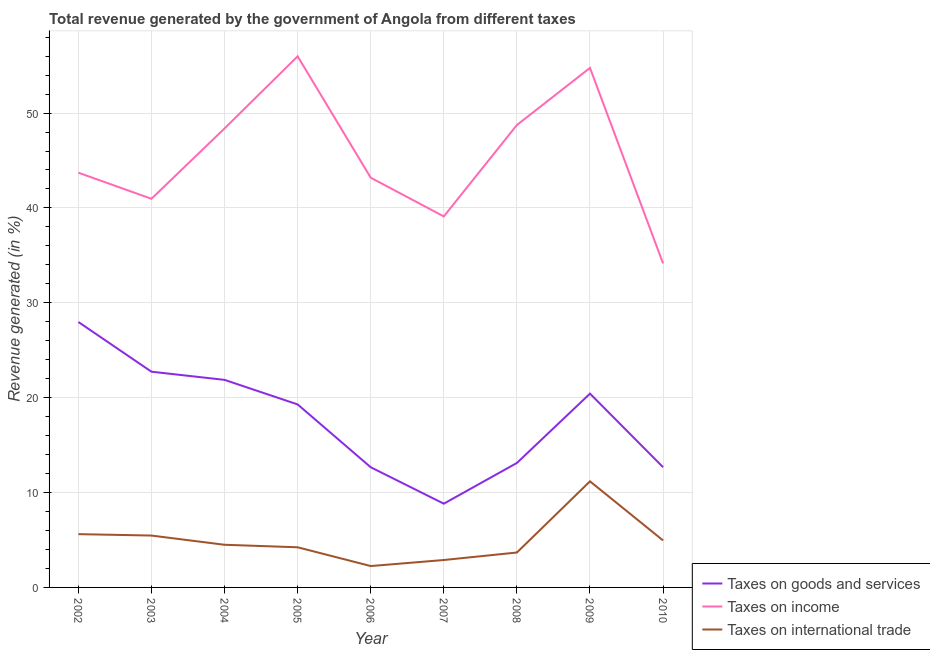Does the line corresponding to percentage of revenue generated by taxes on income intersect with the line corresponding to percentage of revenue generated by tax on international trade?
Your answer should be very brief. No. Is the number of lines equal to the number of legend labels?
Keep it short and to the point. Yes. What is the percentage of revenue generated by tax on international trade in 2007?
Your answer should be very brief. 2.89. Across all years, what is the maximum percentage of revenue generated by taxes on goods and services?
Offer a terse response. 27.98. Across all years, what is the minimum percentage of revenue generated by tax on international trade?
Your response must be concise. 2.25. In which year was the percentage of revenue generated by taxes on income minimum?
Your answer should be very brief. 2010. What is the total percentage of revenue generated by taxes on goods and services in the graph?
Offer a terse response. 159.6. What is the difference between the percentage of revenue generated by taxes on goods and services in 2002 and that in 2003?
Offer a very short reply. 5.24. What is the difference between the percentage of revenue generated by tax on international trade in 2006 and the percentage of revenue generated by taxes on goods and services in 2002?
Offer a very short reply. -25.73. What is the average percentage of revenue generated by tax on international trade per year?
Offer a terse response. 4.97. In the year 2007, what is the difference between the percentage of revenue generated by tax on international trade and percentage of revenue generated by taxes on income?
Ensure brevity in your answer.  -36.22. In how many years, is the percentage of revenue generated by tax on international trade greater than 16 %?
Provide a succinct answer. 0. What is the ratio of the percentage of revenue generated by taxes on goods and services in 2008 to that in 2010?
Offer a very short reply. 1.04. Is the percentage of revenue generated by tax on international trade in 2003 less than that in 2008?
Offer a terse response. No. What is the difference between the highest and the second highest percentage of revenue generated by taxes on goods and services?
Offer a very short reply. 5.24. What is the difference between the highest and the lowest percentage of revenue generated by taxes on goods and services?
Make the answer very short. 19.15. Is it the case that in every year, the sum of the percentage of revenue generated by taxes on goods and services and percentage of revenue generated by taxes on income is greater than the percentage of revenue generated by tax on international trade?
Keep it short and to the point. Yes. Does the percentage of revenue generated by taxes on income monotonically increase over the years?
Make the answer very short. No. Is the percentage of revenue generated by taxes on goods and services strictly greater than the percentage of revenue generated by taxes on income over the years?
Ensure brevity in your answer.  No. How many lines are there?
Your response must be concise. 3. How many years are there in the graph?
Offer a very short reply. 9. What is the difference between two consecutive major ticks on the Y-axis?
Provide a succinct answer. 10. Does the graph contain any zero values?
Offer a terse response. No. Does the graph contain grids?
Give a very brief answer. Yes. How are the legend labels stacked?
Your response must be concise. Vertical. What is the title of the graph?
Offer a very short reply. Total revenue generated by the government of Angola from different taxes. Does "Unemployment benefits" appear as one of the legend labels in the graph?
Give a very brief answer. No. What is the label or title of the Y-axis?
Your answer should be very brief. Revenue generated (in %). What is the Revenue generated (in %) in Taxes on goods and services in 2002?
Provide a short and direct response. 27.98. What is the Revenue generated (in %) of Taxes on income in 2002?
Provide a short and direct response. 43.72. What is the Revenue generated (in %) in Taxes on international trade in 2002?
Your answer should be very brief. 5.62. What is the Revenue generated (in %) of Taxes on goods and services in 2003?
Offer a terse response. 22.74. What is the Revenue generated (in %) of Taxes on income in 2003?
Provide a short and direct response. 40.97. What is the Revenue generated (in %) of Taxes on international trade in 2003?
Keep it short and to the point. 5.47. What is the Revenue generated (in %) of Taxes on goods and services in 2004?
Provide a short and direct response. 21.88. What is the Revenue generated (in %) of Taxes on income in 2004?
Your answer should be compact. 48.38. What is the Revenue generated (in %) in Taxes on international trade in 2004?
Keep it short and to the point. 4.5. What is the Revenue generated (in %) of Taxes on goods and services in 2005?
Keep it short and to the point. 19.29. What is the Revenue generated (in %) of Taxes on income in 2005?
Provide a short and direct response. 55.98. What is the Revenue generated (in %) in Taxes on international trade in 2005?
Your response must be concise. 4.23. What is the Revenue generated (in %) in Taxes on goods and services in 2006?
Your response must be concise. 12.67. What is the Revenue generated (in %) in Taxes on income in 2006?
Keep it short and to the point. 43.19. What is the Revenue generated (in %) of Taxes on international trade in 2006?
Give a very brief answer. 2.25. What is the Revenue generated (in %) of Taxes on goods and services in 2007?
Offer a terse response. 8.83. What is the Revenue generated (in %) in Taxes on income in 2007?
Keep it short and to the point. 39.11. What is the Revenue generated (in %) of Taxes on international trade in 2007?
Make the answer very short. 2.89. What is the Revenue generated (in %) of Taxes on goods and services in 2008?
Your answer should be compact. 13.12. What is the Revenue generated (in %) of Taxes on income in 2008?
Provide a succinct answer. 48.74. What is the Revenue generated (in %) of Taxes on international trade in 2008?
Give a very brief answer. 3.68. What is the Revenue generated (in %) in Taxes on goods and services in 2009?
Ensure brevity in your answer.  20.43. What is the Revenue generated (in %) in Taxes on income in 2009?
Your answer should be very brief. 54.76. What is the Revenue generated (in %) in Taxes on international trade in 2009?
Your response must be concise. 11.18. What is the Revenue generated (in %) of Taxes on goods and services in 2010?
Offer a very short reply. 12.67. What is the Revenue generated (in %) in Taxes on income in 2010?
Ensure brevity in your answer.  34.15. What is the Revenue generated (in %) in Taxes on international trade in 2010?
Provide a short and direct response. 4.95. Across all years, what is the maximum Revenue generated (in %) in Taxes on goods and services?
Provide a short and direct response. 27.98. Across all years, what is the maximum Revenue generated (in %) in Taxes on income?
Make the answer very short. 55.98. Across all years, what is the maximum Revenue generated (in %) of Taxes on international trade?
Offer a very short reply. 11.18. Across all years, what is the minimum Revenue generated (in %) of Taxes on goods and services?
Provide a short and direct response. 8.83. Across all years, what is the minimum Revenue generated (in %) in Taxes on income?
Offer a very short reply. 34.15. Across all years, what is the minimum Revenue generated (in %) of Taxes on international trade?
Keep it short and to the point. 2.25. What is the total Revenue generated (in %) of Taxes on goods and services in the graph?
Your answer should be compact. 159.6. What is the total Revenue generated (in %) of Taxes on income in the graph?
Your answer should be compact. 408.99. What is the total Revenue generated (in %) in Taxes on international trade in the graph?
Give a very brief answer. 44.77. What is the difference between the Revenue generated (in %) of Taxes on goods and services in 2002 and that in 2003?
Your response must be concise. 5.24. What is the difference between the Revenue generated (in %) in Taxes on income in 2002 and that in 2003?
Offer a terse response. 2.75. What is the difference between the Revenue generated (in %) of Taxes on international trade in 2002 and that in 2003?
Give a very brief answer. 0.15. What is the difference between the Revenue generated (in %) of Taxes on goods and services in 2002 and that in 2004?
Give a very brief answer. 6.1. What is the difference between the Revenue generated (in %) in Taxes on income in 2002 and that in 2004?
Make the answer very short. -4.66. What is the difference between the Revenue generated (in %) of Taxes on international trade in 2002 and that in 2004?
Provide a short and direct response. 1.12. What is the difference between the Revenue generated (in %) of Taxes on goods and services in 2002 and that in 2005?
Ensure brevity in your answer.  8.69. What is the difference between the Revenue generated (in %) of Taxes on income in 2002 and that in 2005?
Your response must be concise. -12.27. What is the difference between the Revenue generated (in %) of Taxes on international trade in 2002 and that in 2005?
Provide a succinct answer. 1.39. What is the difference between the Revenue generated (in %) of Taxes on goods and services in 2002 and that in 2006?
Your answer should be compact. 15.31. What is the difference between the Revenue generated (in %) in Taxes on income in 2002 and that in 2006?
Ensure brevity in your answer.  0.53. What is the difference between the Revenue generated (in %) in Taxes on international trade in 2002 and that in 2006?
Your answer should be very brief. 3.36. What is the difference between the Revenue generated (in %) in Taxes on goods and services in 2002 and that in 2007?
Offer a very short reply. 19.15. What is the difference between the Revenue generated (in %) in Taxes on income in 2002 and that in 2007?
Your answer should be very brief. 4.61. What is the difference between the Revenue generated (in %) in Taxes on international trade in 2002 and that in 2007?
Make the answer very short. 2.73. What is the difference between the Revenue generated (in %) of Taxes on goods and services in 2002 and that in 2008?
Ensure brevity in your answer.  14.86. What is the difference between the Revenue generated (in %) of Taxes on income in 2002 and that in 2008?
Give a very brief answer. -5.02. What is the difference between the Revenue generated (in %) of Taxes on international trade in 2002 and that in 2008?
Offer a terse response. 1.94. What is the difference between the Revenue generated (in %) of Taxes on goods and services in 2002 and that in 2009?
Ensure brevity in your answer.  7.55. What is the difference between the Revenue generated (in %) of Taxes on income in 2002 and that in 2009?
Give a very brief answer. -11.04. What is the difference between the Revenue generated (in %) in Taxes on international trade in 2002 and that in 2009?
Ensure brevity in your answer.  -5.57. What is the difference between the Revenue generated (in %) of Taxes on goods and services in 2002 and that in 2010?
Offer a very short reply. 15.31. What is the difference between the Revenue generated (in %) of Taxes on income in 2002 and that in 2010?
Make the answer very short. 9.57. What is the difference between the Revenue generated (in %) of Taxes on international trade in 2002 and that in 2010?
Offer a very short reply. 0.67. What is the difference between the Revenue generated (in %) of Taxes on goods and services in 2003 and that in 2004?
Provide a succinct answer. 0.86. What is the difference between the Revenue generated (in %) of Taxes on income in 2003 and that in 2004?
Your answer should be very brief. -7.41. What is the difference between the Revenue generated (in %) in Taxes on international trade in 2003 and that in 2004?
Keep it short and to the point. 0.97. What is the difference between the Revenue generated (in %) of Taxes on goods and services in 2003 and that in 2005?
Offer a terse response. 3.45. What is the difference between the Revenue generated (in %) in Taxes on income in 2003 and that in 2005?
Your answer should be very brief. -15.02. What is the difference between the Revenue generated (in %) in Taxes on international trade in 2003 and that in 2005?
Keep it short and to the point. 1.24. What is the difference between the Revenue generated (in %) of Taxes on goods and services in 2003 and that in 2006?
Provide a short and direct response. 10.07. What is the difference between the Revenue generated (in %) of Taxes on income in 2003 and that in 2006?
Your answer should be compact. -2.22. What is the difference between the Revenue generated (in %) in Taxes on international trade in 2003 and that in 2006?
Your response must be concise. 3.21. What is the difference between the Revenue generated (in %) in Taxes on goods and services in 2003 and that in 2007?
Your answer should be very brief. 13.91. What is the difference between the Revenue generated (in %) in Taxes on income in 2003 and that in 2007?
Offer a very short reply. 1.86. What is the difference between the Revenue generated (in %) of Taxes on international trade in 2003 and that in 2007?
Offer a very short reply. 2.58. What is the difference between the Revenue generated (in %) in Taxes on goods and services in 2003 and that in 2008?
Your answer should be very brief. 9.62. What is the difference between the Revenue generated (in %) of Taxes on income in 2003 and that in 2008?
Your answer should be compact. -7.78. What is the difference between the Revenue generated (in %) in Taxes on international trade in 2003 and that in 2008?
Your answer should be compact. 1.79. What is the difference between the Revenue generated (in %) of Taxes on goods and services in 2003 and that in 2009?
Your answer should be compact. 2.31. What is the difference between the Revenue generated (in %) of Taxes on income in 2003 and that in 2009?
Offer a terse response. -13.8. What is the difference between the Revenue generated (in %) of Taxes on international trade in 2003 and that in 2009?
Make the answer very short. -5.72. What is the difference between the Revenue generated (in %) in Taxes on goods and services in 2003 and that in 2010?
Keep it short and to the point. 10.07. What is the difference between the Revenue generated (in %) in Taxes on income in 2003 and that in 2010?
Your answer should be compact. 6.82. What is the difference between the Revenue generated (in %) in Taxes on international trade in 2003 and that in 2010?
Your answer should be very brief. 0.52. What is the difference between the Revenue generated (in %) of Taxes on goods and services in 2004 and that in 2005?
Make the answer very short. 2.59. What is the difference between the Revenue generated (in %) of Taxes on income in 2004 and that in 2005?
Give a very brief answer. -7.6. What is the difference between the Revenue generated (in %) of Taxes on international trade in 2004 and that in 2005?
Offer a very short reply. 0.27. What is the difference between the Revenue generated (in %) in Taxes on goods and services in 2004 and that in 2006?
Your response must be concise. 9.21. What is the difference between the Revenue generated (in %) in Taxes on income in 2004 and that in 2006?
Ensure brevity in your answer.  5.19. What is the difference between the Revenue generated (in %) in Taxes on international trade in 2004 and that in 2006?
Ensure brevity in your answer.  2.24. What is the difference between the Revenue generated (in %) in Taxes on goods and services in 2004 and that in 2007?
Your answer should be very brief. 13.05. What is the difference between the Revenue generated (in %) of Taxes on income in 2004 and that in 2007?
Your response must be concise. 9.27. What is the difference between the Revenue generated (in %) of Taxes on international trade in 2004 and that in 2007?
Provide a short and direct response. 1.61. What is the difference between the Revenue generated (in %) in Taxes on goods and services in 2004 and that in 2008?
Keep it short and to the point. 8.76. What is the difference between the Revenue generated (in %) of Taxes on income in 2004 and that in 2008?
Provide a succinct answer. -0.36. What is the difference between the Revenue generated (in %) in Taxes on international trade in 2004 and that in 2008?
Keep it short and to the point. 0.82. What is the difference between the Revenue generated (in %) of Taxes on goods and services in 2004 and that in 2009?
Keep it short and to the point. 1.45. What is the difference between the Revenue generated (in %) of Taxes on income in 2004 and that in 2009?
Your response must be concise. -6.38. What is the difference between the Revenue generated (in %) of Taxes on international trade in 2004 and that in 2009?
Your answer should be very brief. -6.69. What is the difference between the Revenue generated (in %) in Taxes on goods and services in 2004 and that in 2010?
Provide a short and direct response. 9.21. What is the difference between the Revenue generated (in %) of Taxes on income in 2004 and that in 2010?
Offer a terse response. 14.23. What is the difference between the Revenue generated (in %) of Taxes on international trade in 2004 and that in 2010?
Provide a short and direct response. -0.46. What is the difference between the Revenue generated (in %) of Taxes on goods and services in 2005 and that in 2006?
Offer a terse response. 6.62. What is the difference between the Revenue generated (in %) of Taxes on income in 2005 and that in 2006?
Your answer should be compact. 12.79. What is the difference between the Revenue generated (in %) in Taxes on international trade in 2005 and that in 2006?
Offer a very short reply. 1.98. What is the difference between the Revenue generated (in %) of Taxes on goods and services in 2005 and that in 2007?
Offer a very short reply. 10.46. What is the difference between the Revenue generated (in %) in Taxes on income in 2005 and that in 2007?
Offer a very short reply. 16.88. What is the difference between the Revenue generated (in %) in Taxes on international trade in 2005 and that in 2007?
Offer a terse response. 1.34. What is the difference between the Revenue generated (in %) of Taxes on goods and services in 2005 and that in 2008?
Provide a short and direct response. 6.17. What is the difference between the Revenue generated (in %) in Taxes on income in 2005 and that in 2008?
Offer a very short reply. 7.24. What is the difference between the Revenue generated (in %) in Taxes on international trade in 2005 and that in 2008?
Provide a short and direct response. 0.55. What is the difference between the Revenue generated (in %) of Taxes on goods and services in 2005 and that in 2009?
Provide a short and direct response. -1.14. What is the difference between the Revenue generated (in %) in Taxes on income in 2005 and that in 2009?
Your response must be concise. 1.22. What is the difference between the Revenue generated (in %) in Taxes on international trade in 2005 and that in 2009?
Provide a succinct answer. -6.95. What is the difference between the Revenue generated (in %) in Taxes on goods and services in 2005 and that in 2010?
Your answer should be very brief. 6.62. What is the difference between the Revenue generated (in %) of Taxes on income in 2005 and that in 2010?
Your answer should be compact. 21.83. What is the difference between the Revenue generated (in %) in Taxes on international trade in 2005 and that in 2010?
Your answer should be very brief. -0.72. What is the difference between the Revenue generated (in %) of Taxes on goods and services in 2006 and that in 2007?
Keep it short and to the point. 3.84. What is the difference between the Revenue generated (in %) in Taxes on income in 2006 and that in 2007?
Make the answer very short. 4.08. What is the difference between the Revenue generated (in %) in Taxes on international trade in 2006 and that in 2007?
Give a very brief answer. -0.64. What is the difference between the Revenue generated (in %) of Taxes on goods and services in 2006 and that in 2008?
Give a very brief answer. -0.45. What is the difference between the Revenue generated (in %) in Taxes on income in 2006 and that in 2008?
Keep it short and to the point. -5.55. What is the difference between the Revenue generated (in %) in Taxes on international trade in 2006 and that in 2008?
Ensure brevity in your answer.  -1.43. What is the difference between the Revenue generated (in %) of Taxes on goods and services in 2006 and that in 2009?
Offer a terse response. -7.76. What is the difference between the Revenue generated (in %) of Taxes on income in 2006 and that in 2009?
Your response must be concise. -11.57. What is the difference between the Revenue generated (in %) of Taxes on international trade in 2006 and that in 2009?
Ensure brevity in your answer.  -8.93. What is the difference between the Revenue generated (in %) in Taxes on goods and services in 2006 and that in 2010?
Keep it short and to the point. -0.01. What is the difference between the Revenue generated (in %) in Taxes on income in 2006 and that in 2010?
Your response must be concise. 9.04. What is the difference between the Revenue generated (in %) of Taxes on international trade in 2006 and that in 2010?
Give a very brief answer. -2.7. What is the difference between the Revenue generated (in %) of Taxes on goods and services in 2007 and that in 2008?
Keep it short and to the point. -4.29. What is the difference between the Revenue generated (in %) of Taxes on income in 2007 and that in 2008?
Make the answer very short. -9.64. What is the difference between the Revenue generated (in %) in Taxes on international trade in 2007 and that in 2008?
Make the answer very short. -0.79. What is the difference between the Revenue generated (in %) of Taxes on goods and services in 2007 and that in 2009?
Keep it short and to the point. -11.6. What is the difference between the Revenue generated (in %) in Taxes on income in 2007 and that in 2009?
Provide a short and direct response. -15.66. What is the difference between the Revenue generated (in %) in Taxes on international trade in 2007 and that in 2009?
Offer a very short reply. -8.29. What is the difference between the Revenue generated (in %) in Taxes on goods and services in 2007 and that in 2010?
Provide a succinct answer. -3.85. What is the difference between the Revenue generated (in %) in Taxes on income in 2007 and that in 2010?
Offer a very short reply. 4.96. What is the difference between the Revenue generated (in %) in Taxes on international trade in 2007 and that in 2010?
Keep it short and to the point. -2.06. What is the difference between the Revenue generated (in %) of Taxes on goods and services in 2008 and that in 2009?
Your answer should be very brief. -7.31. What is the difference between the Revenue generated (in %) of Taxes on income in 2008 and that in 2009?
Ensure brevity in your answer.  -6.02. What is the difference between the Revenue generated (in %) in Taxes on international trade in 2008 and that in 2009?
Provide a short and direct response. -7.5. What is the difference between the Revenue generated (in %) in Taxes on goods and services in 2008 and that in 2010?
Your response must be concise. 0.45. What is the difference between the Revenue generated (in %) in Taxes on income in 2008 and that in 2010?
Offer a terse response. 14.59. What is the difference between the Revenue generated (in %) of Taxes on international trade in 2008 and that in 2010?
Make the answer very short. -1.27. What is the difference between the Revenue generated (in %) in Taxes on goods and services in 2009 and that in 2010?
Ensure brevity in your answer.  7.75. What is the difference between the Revenue generated (in %) in Taxes on income in 2009 and that in 2010?
Your response must be concise. 20.61. What is the difference between the Revenue generated (in %) of Taxes on international trade in 2009 and that in 2010?
Keep it short and to the point. 6.23. What is the difference between the Revenue generated (in %) in Taxes on goods and services in 2002 and the Revenue generated (in %) in Taxes on income in 2003?
Keep it short and to the point. -12.99. What is the difference between the Revenue generated (in %) of Taxes on goods and services in 2002 and the Revenue generated (in %) of Taxes on international trade in 2003?
Provide a short and direct response. 22.51. What is the difference between the Revenue generated (in %) of Taxes on income in 2002 and the Revenue generated (in %) of Taxes on international trade in 2003?
Offer a very short reply. 38.25. What is the difference between the Revenue generated (in %) in Taxes on goods and services in 2002 and the Revenue generated (in %) in Taxes on income in 2004?
Provide a succinct answer. -20.4. What is the difference between the Revenue generated (in %) of Taxes on goods and services in 2002 and the Revenue generated (in %) of Taxes on international trade in 2004?
Keep it short and to the point. 23.48. What is the difference between the Revenue generated (in %) in Taxes on income in 2002 and the Revenue generated (in %) in Taxes on international trade in 2004?
Your response must be concise. 39.22. What is the difference between the Revenue generated (in %) in Taxes on goods and services in 2002 and the Revenue generated (in %) in Taxes on income in 2005?
Provide a short and direct response. -28. What is the difference between the Revenue generated (in %) in Taxes on goods and services in 2002 and the Revenue generated (in %) in Taxes on international trade in 2005?
Make the answer very short. 23.75. What is the difference between the Revenue generated (in %) in Taxes on income in 2002 and the Revenue generated (in %) in Taxes on international trade in 2005?
Offer a very short reply. 39.49. What is the difference between the Revenue generated (in %) in Taxes on goods and services in 2002 and the Revenue generated (in %) in Taxes on income in 2006?
Provide a short and direct response. -15.21. What is the difference between the Revenue generated (in %) of Taxes on goods and services in 2002 and the Revenue generated (in %) of Taxes on international trade in 2006?
Your answer should be compact. 25.73. What is the difference between the Revenue generated (in %) of Taxes on income in 2002 and the Revenue generated (in %) of Taxes on international trade in 2006?
Give a very brief answer. 41.46. What is the difference between the Revenue generated (in %) in Taxes on goods and services in 2002 and the Revenue generated (in %) in Taxes on income in 2007?
Offer a terse response. -11.13. What is the difference between the Revenue generated (in %) in Taxes on goods and services in 2002 and the Revenue generated (in %) in Taxes on international trade in 2007?
Your answer should be very brief. 25.09. What is the difference between the Revenue generated (in %) in Taxes on income in 2002 and the Revenue generated (in %) in Taxes on international trade in 2007?
Keep it short and to the point. 40.83. What is the difference between the Revenue generated (in %) of Taxes on goods and services in 2002 and the Revenue generated (in %) of Taxes on income in 2008?
Ensure brevity in your answer.  -20.76. What is the difference between the Revenue generated (in %) of Taxes on goods and services in 2002 and the Revenue generated (in %) of Taxes on international trade in 2008?
Provide a succinct answer. 24.3. What is the difference between the Revenue generated (in %) in Taxes on income in 2002 and the Revenue generated (in %) in Taxes on international trade in 2008?
Your response must be concise. 40.04. What is the difference between the Revenue generated (in %) in Taxes on goods and services in 2002 and the Revenue generated (in %) in Taxes on income in 2009?
Your answer should be very brief. -26.78. What is the difference between the Revenue generated (in %) in Taxes on goods and services in 2002 and the Revenue generated (in %) in Taxes on international trade in 2009?
Make the answer very short. 16.8. What is the difference between the Revenue generated (in %) in Taxes on income in 2002 and the Revenue generated (in %) in Taxes on international trade in 2009?
Provide a short and direct response. 32.53. What is the difference between the Revenue generated (in %) of Taxes on goods and services in 2002 and the Revenue generated (in %) of Taxes on income in 2010?
Provide a short and direct response. -6.17. What is the difference between the Revenue generated (in %) of Taxes on goods and services in 2002 and the Revenue generated (in %) of Taxes on international trade in 2010?
Offer a terse response. 23.03. What is the difference between the Revenue generated (in %) in Taxes on income in 2002 and the Revenue generated (in %) in Taxes on international trade in 2010?
Ensure brevity in your answer.  38.76. What is the difference between the Revenue generated (in %) of Taxes on goods and services in 2003 and the Revenue generated (in %) of Taxes on income in 2004?
Provide a short and direct response. -25.64. What is the difference between the Revenue generated (in %) in Taxes on goods and services in 2003 and the Revenue generated (in %) in Taxes on international trade in 2004?
Your response must be concise. 18.24. What is the difference between the Revenue generated (in %) of Taxes on income in 2003 and the Revenue generated (in %) of Taxes on international trade in 2004?
Your answer should be compact. 36.47. What is the difference between the Revenue generated (in %) of Taxes on goods and services in 2003 and the Revenue generated (in %) of Taxes on income in 2005?
Ensure brevity in your answer.  -33.24. What is the difference between the Revenue generated (in %) in Taxes on goods and services in 2003 and the Revenue generated (in %) in Taxes on international trade in 2005?
Offer a very short reply. 18.51. What is the difference between the Revenue generated (in %) in Taxes on income in 2003 and the Revenue generated (in %) in Taxes on international trade in 2005?
Your response must be concise. 36.73. What is the difference between the Revenue generated (in %) in Taxes on goods and services in 2003 and the Revenue generated (in %) in Taxes on income in 2006?
Provide a succinct answer. -20.45. What is the difference between the Revenue generated (in %) in Taxes on goods and services in 2003 and the Revenue generated (in %) in Taxes on international trade in 2006?
Your response must be concise. 20.48. What is the difference between the Revenue generated (in %) of Taxes on income in 2003 and the Revenue generated (in %) of Taxes on international trade in 2006?
Ensure brevity in your answer.  38.71. What is the difference between the Revenue generated (in %) of Taxes on goods and services in 2003 and the Revenue generated (in %) of Taxes on income in 2007?
Make the answer very short. -16.37. What is the difference between the Revenue generated (in %) in Taxes on goods and services in 2003 and the Revenue generated (in %) in Taxes on international trade in 2007?
Provide a succinct answer. 19.85. What is the difference between the Revenue generated (in %) of Taxes on income in 2003 and the Revenue generated (in %) of Taxes on international trade in 2007?
Offer a very short reply. 38.08. What is the difference between the Revenue generated (in %) of Taxes on goods and services in 2003 and the Revenue generated (in %) of Taxes on income in 2008?
Ensure brevity in your answer.  -26. What is the difference between the Revenue generated (in %) of Taxes on goods and services in 2003 and the Revenue generated (in %) of Taxes on international trade in 2008?
Your response must be concise. 19.06. What is the difference between the Revenue generated (in %) in Taxes on income in 2003 and the Revenue generated (in %) in Taxes on international trade in 2008?
Your answer should be very brief. 37.29. What is the difference between the Revenue generated (in %) in Taxes on goods and services in 2003 and the Revenue generated (in %) in Taxes on income in 2009?
Ensure brevity in your answer.  -32.02. What is the difference between the Revenue generated (in %) of Taxes on goods and services in 2003 and the Revenue generated (in %) of Taxes on international trade in 2009?
Offer a very short reply. 11.56. What is the difference between the Revenue generated (in %) in Taxes on income in 2003 and the Revenue generated (in %) in Taxes on international trade in 2009?
Keep it short and to the point. 29.78. What is the difference between the Revenue generated (in %) in Taxes on goods and services in 2003 and the Revenue generated (in %) in Taxes on income in 2010?
Ensure brevity in your answer.  -11.41. What is the difference between the Revenue generated (in %) in Taxes on goods and services in 2003 and the Revenue generated (in %) in Taxes on international trade in 2010?
Provide a short and direct response. 17.79. What is the difference between the Revenue generated (in %) in Taxes on income in 2003 and the Revenue generated (in %) in Taxes on international trade in 2010?
Offer a terse response. 36.01. What is the difference between the Revenue generated (in %) of Taxes on goods and services in 2004 and the Revenue generated (in %) of Taxes on income in 2005?
Provide a succinct answer. -34.11. What is the difference between the Revenue generated (in %) of Taxes on goods and services in 2004 and the Revenue generated (in %) of Taxes on international trade in 2005?
Offer a very short reply. 17.65. What is the difference between the Revenue generated (in %) of Taxes on income in 2004 and the Revenue generated (in %) of Taxes on international trade in 2005?
Provide a succinct answer. 44.15. What is the difference between the Revenue generated (in %) in Taxes on goods and services in 2004 and the Revenue generated (in %) in Taxes on income in 2006?
Provide a short and direct response. -21.31. What is the difference between the Revenue generated (in %) in Taxes on goods and services in 2004 and the Revenue generated (in %) in Taxes on international trade in 2006?
Make the answer very short. 19.62. What is the difference between the Revenue generated (in %) of Taxes on income in 2004 and the Revenue generated (in %) of Taxes on international trade in 2006?
Your answer should be very brief. 46.12. What is the difference between the Revenue generated (in %) of Taxes on goods and services in 2004 and the Revenue generated (in %) of Taxes on income in 2007?
Give a very brief answer. -17.23. What is the difference between the Revenue generated (in %) in Taxes on goods and services in 2004 and the Revenue generated (in %) in Taxes on international trade in 2007?
Ensure brevity in your answer.  18.99. What is the difference between the Revenue generated (in %) of Taxes on income in 2004 and the Revenue generated (in %) of Taxes on international trade in 2007?
Offer a terse response. 45.49. What is the difference between the Revenue generated (in %) of Taxes on goods and services in 2004 and the Revenue generated (in %) of Taxes on income in 2008?
Ensure brevity in your answer.  -26.86. What is the difference between the Revenue generated (in %) in Taxes on goods and services in 2004 and the Revenue generated (in %) in Taxes on international trade in 2008?
Offer a very short reply. 18.2. What is the difference between the Revenue generated (in %) of Taxes on income in 2004 and the Revenue generated (in %) of Taxes on international trade in 2008?
Offer a very short reply. 44.7. What is the difference between the Revenue generated (in %) of Taxes on goods and services in 2004 and the Revenue generated (in %) of Taxes on income in 2009?
Your answer should be compact. -32.88. What is the difference between the Revenue generated (in %) of Taxes on goods and services in 2004 and the Revenue generated (in %) of Taxes on international trade in 2009?
Your answer should be very brief. 10.69. What is the difference between the Revenue generated (in %) in Taxes on income in 2004 and the Revenue generated (in %) in Taxes on international trade in 2009?
Offer a terse response. 37.2. What is the difference between the Revenue generated (in %) in Taxes on goods and services in 2004 and the Revenue generated (in %) in Taxes on income in 2010?
Offer a terse response. -12.27. What is the difference between the Revenue generated (in %) of Taxes on goods and services in 2004 and the Revenue generated (in %) of Taxes on international trade in 2010?
Your response must be concise. 16.93. What is the difference between the Revenue generated (in %) of Taxes on income in 2004 and the Revenue generated (in %) of Taxes on international trade in 2010?
Provide a succinct answer. 43.43. What is the difference between the Revenue generated (in %) in Taxes on goods and services in 2005 and the Revenue generated (in %) in Taxes on income in 2006?
Offer a very short reply. -23.9. What is the difference between the Revenue generated (in %) of Taxes on goods and services in 2005 and the Revenue generated (in %) of Taxes on international trade in 2006?
Make the answer very short. 17.04. What is the difference between the Revenue generated (in %) of Taxes on income in 2005 and the Revenue generated (in %) of Taxes on international trade in 2006?
Ensure brevity in your answer.  53.73. What is the difference between the Revenue generated (in %) in Taxes on goods and services in 2005 and the Revenue generated (in %) in Taxes on income in 2007?
Keep it short and to the point. -19.81. What is the difference between the Revenue generated (in %) in Taxes on goods and services in 2005 and the Revenue generated (in %) in Taxes on international trade in 2007?
Provide a short and direct response. 16.4. What is the difference between the Revenue generated (in %) of Taxes on income in 2005 and the Revenue generated (in %) of Taxes on international trade in 2007?
Give a very brief answer. 53.09. What is the difference between the Revenue generated (in %) of Taxes on goods and services in 2005 and the Revenue generated (in %) of Taxes on income in 2008?
Your answer should be compact. -29.45. What is the difference between the Revenue generated (in %) of Taxes on goods and services in 2005 and the Revenue generated (in %) of Taxes on international trade in 2008?
Provide a short and direct response. 15.61. What is the difference between the Revenue generated (in %) of Taxes on income in 2005 and the Revenue generated (in %) of Taxes on international trade in 2008?
Your answer should be very brief. 52.3. What is the difference between the Revenue generated (in %) in Taxes on goods and services in 2005 and the Revenue generated (in %) in Taxes on income in 2009?
Your response must be concise. -35.47. What is the difference between the Revenue generated (in %) of Taxes on goods and services in 2005 and the Revenue generated (in %) of Taxes on international trade in 2009?
Ensure brevity in your answer.  8.11. What is the difference between the Revenue generated (in %) of Taxes on income in 2005 and the Revenue generated (in %) of Taxes on international trade in 2009?
Offer a terse response. 44.8. What is the difference between the Revenue generated (in %) of Taxes on goods and services in 2005 and the Revenue generated (in %) of Taxes on income in 2010?
Your response must be concise. -14.86. What is the difference between the Revenue generated (in %) of Taxes on goods and services in 2005 and the Revenue generated (in %) of Taxes on international trade in 2010?
Your response must be concise. 14.34. What is the difference between the Revenue generated (in %) of Taxes on income in 2005 and the Revenue generated (in %) of Taxes on international trade in 2010?
Offer a very short reply. 51.03. What is the difference between the Revenue generated (in %) of Taxes on goods and services in 2006 and the Revenue generated (in %) of Taxes on income in 2007?
Your answer should be very brief. -26.44. What is the difference between the Revenue generated (in %) in Taxes on goods and services in 2006 and the Revenue generated (in %) in Taxes on international trade in 2007?
Provide a short and direct response. 9.78. What is the difference between the Revenue generated (in %) in Taxes on income in 2006 and the Revenue generated (in %) in Taxes on international trade in 2007?
Ensure brevity in your answer.  40.3. What is the difference between the Revenue generated (in %) of Taxes on goods and services in 2006 and the Revenue generated (in %) of Taxes on income in 2008?
Ensure brevity in your answer.  -36.07. What is the difference between the Revenue generated (in %) in Taxes on goods and services in 2006 and the Revenue generated (in %) in Taxes on international trade in 2008?
Your response must be concise. 8.99. What is the difference between the Revenue generated (in %) in Taxes on income in 2006 and the Revenue generated (in %) in Taxes on international trade in 2008?
Give a very brief answer. 39.51. What is the difference between the Revenue generated (in %) in Taxes on goods and services in 2006 and the Revenue generated (in %) in Taxes on income in 2009?
Your answer should be compact. -42.09. What is the difference between the Revenue generated (in %) in Taxes on goods and services in 2006 and the Revenue generated (in %) in Taxes on international trade in 2009?
Offer a terse response. 1.48. What is the difference between the Revenue generated (in %) in Taxes on income in 2006 and the Revenue generated (in %) in Taxes on international trade in 2009?
Your answer should be very brief. 32.01. What is the difference between the Revenue generated (in %) of Taxes on goods and services in 2006 and the Revenue generated (in %) of Taxes on income in 2010?
Your response must be concise. -21.48. What is the difference between the Revenue generated (in %) of Taxes on goods and services in 2006 and the Revenue generated (in %) of Taxes on international trade in 2010?
Provide a short and direct response. 7.72. What is the difference between the Revenue generated (in %) in Taxes on income in 2006 and the Revenue generated (in %) in Taxes on international trade in 2010?
Offer a very short reply. 38.24. What is the difference between the Revenue generated (in %) of Taxes on goods and services in 2007 and the Revenue generated (in %) of Taxes on income in 2008?
Make the answer very short. -39.91. What is the difference between the Revenue generated (in %) in Taxes on goods and services in 2007 and the Revenue generated (in %) in Taxes on international trade in 2008?
Make the answer very short. 5.15. What is the difference between the Revenue generated (in %) in Taxes on income in 2007 and the Revenue generated (in %) in Taxes on international trade in 2008?
Offer a very short reply. 35.43. What is the difference between the Revenue generated (in %) in Taxes on goods and services in 2007 and the Revenue generated (in %) in Taxes on income in 2009?
Ensure brevity in your answer.  -45.93. What is the difference between the Revenue generated (in %) in Taxes on goods and services in 2007 and the Revenue generated (in %) in Taxes on international trade in 2009?
Keep it short and to the point. -2.36. What is the difference between the Revenue generated (in %) of Taxes on income in 2007 and the Revenue generated (in %) of Taxes on international trade in 2009?
Make the answer very short. 27.92. What is the difference between the Revenue generated (in %) of Taxes on goods and services in 2007 and the Revenue generated (in %) of Taxes on income in 2010?
Your answer should be compact. -25.32. What is the difference between the Revenue generated (in %) of Taxes on goods and services in 2007 and the Revenue generated (in %) of Taxes on international trade in 2010?
Your answer should be compact. 3.87. What is the difference between the Revenue generated (in %) of Taxes on income in 2007 and the Revenue generated (in %) of Taxes on international trade in 2010?
Provide a succinct answer. 34.15. What is the difference between the Revenue generated (in %) in Taxes on goods and services in 2008 and the Revenue generated (in %) in Taxes on income in 2009?
Ensure brevity in your answer.  -41.64. What is the difference between the Revenue generated (in %) of Taxes on goods and services in 2008 and the Revenue generated (in %) of Taxes on international trade in 2009?
Give a very brief answer. 1.94. What is the difference between the Revenue generated (in %) in Taxes on income in 2008 and the Revenue generated (in %) in Taxes on international trade in 2009?
Ensure brevity in your answer.  37.56. What is the difference between the Revenue generated (in %) in Taxes on goods and services in 2008 and the Revenue generated (in %) in Taxes on income in 2010?
Give a very brief answer. -21.03. What is the difference between the Revenue generated (in %) of Taxes on goods and services in 2008 and the Revenue generated (in %) of Taxes on international trade in 2010?
Ensure brevity in your answer.  8.17. What is the difference between the Revenue generated (in %) in Taxes on income in 2008 and the Revenue generated (in %) in Taxes on international trade in 2010?
Your answer should be compact. 43.79. What is the difference between the Revenue generated (in %) of Taxes on goods and services in 2009 and the Revenue generated (in %) of Taxes on income in 2010?
Your answer should be compact. -13.72. What is the difference between the Revenue generated (in %) of Taxes on goods and services in 2009 and the Revenue generated (in %) of Taxes on international trade in 2010?
Provide a short and direct response. 15.48. What is the difference between the Revenue generated (in %) in Taxes on income in 2009 and the Revenue generated (in %) in Taxes on international trade in 2010?
Your answer should be compact. 49.81. What is the average Revenue generated (in %) in Taxes on goods and services per year?
Offer a very short reply. 17.73. What is the average Revenue generated (in %) of Taxes on income per year?
Keep it short and to the point. 45.44. What is the average Revenue generated (in %) in Taxes on international trade per year?
Provide a short and direct response. 4.97. In the year 2002, what is the difference between the Revenue generated (in %) in Taxes on goods and services and Revenue generated (in %) in Taxes on income?
Keep it short and to the point. -15.74. In the year 2002, what is the difference between the Revenue generated (in %) in Taxes on goods and services and Revenue generated (in %) in Taxes on international trade?
Provide a short and direct response. 22.36. In the year 2002, what is the difference between the Revenue generated (in %) of Taxes on income and Revenue generated (in %) of Taxes on international trade?
Your response must be concise. 38.1. In the year 2003, what is the difference between the Revenue generated (in %) of Taxes on goods and services and Revenue generated (in %) of Taxes on income?
Offer a terse response. -18.23. In the year 2003, what is the difference between the Revenue generated (in %) of Taxes on goods and services and Revenue generated (in %) of Taxes on international trade?
Your answer should be compact. 17.27. In the year 2003, what is the difference between the Revenue generated (in %) of Taxes on income and Revenue generated (in %) of Taxes on international trade?
Make the answer very short. 35.5. In the year 2004, what is the difference between the Revenue generated (in %) of Taxes on goods and services and Revenue generated (in %) of Taxes on income?
Offer a very short reply. -26.5. In the year 2004, what is the difference between the Revenue generated (in %) of Taxes on goods and services and Revenue generated (in %) of Taxes on international trade?
Your response must be concise. 17.38. In the year 2004, what is the difference between the Revenue generated (in %) in Taxes on income and Revenue generated (in %) in Taxes on international trade?
Your response must be concise. 43.88. In the year 2005, what is the difference between the Revenue generated (in %) in Taxes on goods and services and Revenue generated (in %) in Taxes on income?
Provide a short and direct response. -36.69. In the year 2005, what is the difference between the Revenue generated (in %) of Taxes on goods and services and Revenue generated (in %) of Taxes on international trade?
Make the answer very short. 15.06. In the year 2005, what is the difference between the Revenue generated (in %) of Taxes on income and Revenue generated (in %) of Taxes on international trade?
Your answer should be very brief. 51.75. In the year 2006, what is the difference between the Revenue generated (in %) of Taxes on goods and services and Revenue generated (in %) of Taxes on income?
Give a very brief answer. -30.52. In the year 2006, what is the difference between the Revenue generated (in %) of Taxes on goods and services and Revenue generated (in %) of Taxes on international trade?
Offer a terse response. 10.41. In the year 2006, what is the difference between the Revenue generated (in %) in Taxes on income and Revenue generated (in %) in Taxes on international trade?
Your answer should be very brief. 40.93. In the year 2007, what is the difference between the Revenue generated (in %) in Taxes on goods and services and Revenue generated (in %) in Taxes on income?
Your response must be concise. -30.28. In the year 2007, what is the difference between the Revenue generated (in %) of Taxes on goods and services and Revenue generated (in %) of Taxes on international trade?
Provide a succinct answer. 5.94. In the year 2007, what is the difference between the Revenue generated (in %) in Taxes on income and Revenue generated (in %) in Taxes on international trade?
Your answer should be compact. 36.22. In the year 2008, what is the difference between the Revenue generated (in %) of Taxes on goods and services and Revenue generated (in %) of Taxes on income?
Ensure brevity in your answer.  -35.62. In the year 2008, what is the difference between the Revenue generated (in %) in Taxes on goods and services and Revenue generated (in %) in Taxes on international trade?
Provide a succinct answer. 9.44. In the year 2008, what is the difference between the Revenue generated (in %) of Taxes on income and Revenue generated (in %) of Taxes on international trade?
Your answer should be compact. 45.06. In the year 2009, what is the difference between the Revenue generated (in %) in Taxes on goods and services and Revenue generated (in %) in Taxes on income?
Provide a succinct answer. -34.33. In the year 2009, what is the difference between the Revenue generated (in %) in Taxes on goods and services and Revenue generated (in %) in Taxes on international trade?
Your response must be concise. 9.24. In the year 2009, what is the difference between the Revenue generated (in %) of Taxes on income and Revenue generated (in %) of Taxes on international trade?
Your response must be concise. 43.58. In the year 2010, what is the difference between the Revenue generated (in %) of Taxes on goods and services and Revenue generated (in %) of Taxes on income?
Ensure brevity in your answer.  -21.48. In the year 2010, what is the difference between the Revenue generated (in %) in Taxes on goods and services and Revenue generated (in %) in Taxes on international trade?
Offer a very short reply. 7.72. In the year 2010, what is the difference between the Revenue generated (in %) of Taxes on income and Revenue generated (in %) of Taxes on international trade?
Provide a short and direct response. 29.2. What is the ratio of the Revenue generated (in %) in Taxes on goods and services in 2002 to that in 2003?
Offer a terse response. 1.23. What is the ratio of the Revenue generated (in %) of Taxes on income in 2002 to that in 2003?
Provide a succinct answer. 1.07. What is the ratio of the Revenue generated (in %) in Taxes on international trade in 2002 to that in 2003?
Make the answer very short. 1.03. What is the ratio of the Revenue generated (in %) in Taxes on goods and services in 2002 to that in 2004?
Offer a terse response. 1.28. What is the ratio of the Revenue generated (in %) in Taxes on income in 2002 to that in 2004?
Keep it short and to the point. 0.9. What is the ratio of the Revenue generated (in %) in Taxes on international trade in 2002 to that in 2004?
Offer a terse response. 1.25. What is the ratio of the Revenue generated (in %) in Taxes on goods and services in 2002 to that in 2005?
Offer a terse response. 1.45. What is the ratio of the Revenue generated (in %) in Taxes on income in 2002 to that in 2005?
Ensure brevity in your answer.  0.78. What is the ratio of the Revenue generated (in %) of Taxes on international trade in 2002 to that in 2005?
Keep it short and to the point. 1.33. What is the ratio of the Revenue generated (in %) of Taxes on goods and services in 2002 to that in 2006?
Ensure brevity in your answer.  2.21. What is the ratio of the Revenue generated (in %) in Taxes on income in 2002 to that in 2006?
Your answer should be compact. 1.01. What is the ratio of the Revenue generated (in %) of Taxes on international trade in 2002 to that in 2006?
Offer a very short reply. 2.49. What is the ratio of the Revenue generated (in %) in Taxes on goods and services in 2002 to that in 2007?
Offer a very short reply. 3.17. What is the ratio of the Revenue generated (in %) in Taxes on income in 2002 to that in 2007?
Your answer should be very brief. 1.12. What is the ratio of the Revenue generated (in %) in Taxes on international trade in 2002 to that in 2007?
Offer a terse response. 1.94. What is the ratio of the Revenue generated (in %) of Taxes on goods and services in 2002 to that in 2008?
Your answer should be compact. 2.13. What is the ratio of the Revenue generated (in %) in Taxes on income in 2002 to that in 2008?
Give a very brief answer. 0.9. What is the ratio of the Revenue generated (in %) of Taxes on international trade in 2002 to that in 2008?
Your response must be concise. 1.53. What is the ratio of the Revenue generated (in %) in Taxes on goods and services in 2002 to that in 2009?
Your answer should be compact. 1.37. What is the ratio of the Revenue generated (in %) in Taxes on income in 2002 to that in 2009?
Your response must be concise. 0.8. What is the ratio of the Revenue generated (in %) in Taxes on international trade in 2002 to that in 2009?
Ensure brevity in your answer.  0.5. What is the ratio of the Revenue generated (in %) of Taxes on goods and services in 2002 to that in 2010?
Give a very brief answer. 2.21. What is the ratio of the Revenue generated (in %) of Taxes on income in 2002 to that in 2010?
Your response must be concise. 1.28. What is the ratio of the Revenue generated (in %) in Taxes on international trade in 2002 to that in 2010?
Offer a very short reply. 1.13. What is the ratio of the Revenue generated (in %) in Taxes on goods and services in 2003 to that in 2004?
Offer a very short reply. 1.04. What is the ratio of the Revenue generated (in %) in Taxes on income in 2003 to that in 2004?
Give a very brief answer. 0.85. What is the ratio of the Revenue generated (in %) in Taxes on international trade in 2003 to that in 2004?
Offer a very short reply. 1.22. What is the ratio of the Revenue generated (in %) of Taxes on goods and services in 2003 to that in 2005?
Offer a terse response. 1.18. What is the ratio of the Revenue generated (in %) in Taxes on income in 2003 to that in 2005?
Offer a very short reply. 0.73. What is the ratio of the Revenue generated (in %) of Taxes on international trade in 2003 to that in 2005?
Your answer should be very brief. 1.29. What is the ratio of the Revenue generated (in %) of Taxes on goods and services in 2003 to that in 2006?
Your answer should be compact. 1.8. What is the ratio of the Revenue generated (in %) of Taxes on income in 2003 to that in 2006?
Your response must be concise. 0.95. What is the ratio of the Revenue generated (in %) in Taxes on international trade in 2003 to that in 2006?
Your answer should be compact. 2.43. What is the ratio of the Revenue generated (in %) in Taxes on goods and services in 2003 to that in 2007?
Your answer should be very brief. 2.58. What is the ratio of the Revenue generated (in %) in Taxes on income in 2003 to that in 2007?
Ensure brevity in your answer.  1.05. What is the ratio of the Revenue generated (in %) of Taxes on international trade in 2003 to that in 2007?
Offer a very short reply. 1.89. What is the ratio of the Revenue generated (in %) of Taxes on goods and services in 2003 to that in 2008?
Provide a succinct answer. 1.73. What is the ratio of the Revenue generated (in %) in Taxes on income in 2003 to that in 2008?
Make the answer very short. 0.84. What is the ratio of the Revenue generated (in %) in Taxes on international trade in 2003 to that in 2008?
Your answer should be compact. 1.49. What is the ratio of the Revenue generated (in %) of Taxes on goods and services in 2003 to that in 2009?
Your answer should be compact. 1.11. What is the ratio of the Revenue generated (in %) in Taxes on income in 2003 to that in 2009?
Offer a very short reply. 0.75. What is the ratio of the Revenue generated (in %) of Taxes on international trade in 2003 to that in 2009?
Offer a terse response. 0.49. What is the ratio of the Revenue generated (in %) in Taxes on goods and services in 2003 to that in 2010?
Keep it short and to the point. 1.79. What is the ratio of the Revenue generated (in %) of Taxes on income in 2003 to that in 2010?
Provide a succinct answer. 1.2. What is the ratio of the Revenue generated (in %) of Taxes on international trade in 2003 to that in 2010?
Ensure brevity in your answer.  1.1. What is the ratio of the Revenue generated (in %) of Taxes on goods and services in 2004 to that in 2005?
Your answer should be very brief. 1.13. What is the ratio of the Revenue generated (in %) in Taxes on income in 2004 to that in 2005?
Ensure brevity in your answer.  0.86. What is the ratio of the Revenue generated (in %) of Taxes on international trade in 2004 to that in 2005?
Offer a terse response. 1.06. What is the ratio of the Revenue generated (in %) of Taxes on goods and services in 2004 to that in 2006?
Keep it short and to the point. 1.73. What is the ratio of the Revenue generated (in %) of Taxes on income in 2004 to that in 2006?
Your answer should be very brief. 1.12. What is the ratio of the Revenue generated (in %) of Taxes on international trade in 2004 to that in 2006?
Your response must be concise. 1.99. What is the ratio of the Revenue generated (in %) of Taxes on goods and services in 2004 to that in 2007?
Offer a very short reply. 2.48. What is the ratio of the Revenue generated (in %) in Taxes on income in 2004 to that in 2007?
Make the answer very short. 1.24. What is the ratio of the Revenue generated (in %) of Taxes on international trade in 2004 to that in 2007?
Make the answer very short. 1.56. What is the ratio of the Revenue generated (in %) of Taxes on goods and services in 2004 to that in 2008?
Keep it short and to the point. 1.67. What is the ratio of the Revenue generated (in %) of Taxes on income in 2004 to that in 2008?
Offer a very short reply. 0.99. What is the ratio of the Revenue generated (in %) in Taxes on international trade in 2004 to that in 2008?
Give a very brief answer. 1.22. What is the ratio of the Revenue generated (in %) in Taxes on goods and services in 2004 to that in 2009?
Your answer should be very brief. 1.07. What is the ratio of the Revenue generated (in %) of Taxes on income in 2004 to that in 2009?
Provide a short and direct response. 0.88. What is the ratio of the Revenue generated (in %) of Taxes on international trade in 2004 to that in 2009?
Offer a terse response. 0.4. What is the ratio of the Revenue generated (in %) in Taxes on goods and services in 2004 to that in 2010?
Your response must be concise. 1.73. What is the ratio of the Revenue generated (in %) in Taxes on income in 2004 to that in 2010?
Provide a succinct answer. 1.42. What is the ratio of the Revenue generated (in %) of Taxes on international trade in 2004 to that in 2010?
Give a very brief answer. 0.91. What is the ratio of the Revenue generated (in %) of Taxes on goods and services in 2005 to that in 2006?
Ensure brevity in your answer.  1.52. What is the ratio of the Revenue generated (in %) of Taxes on income in 2005 to that in 2006?
Your response must be concise. 1.3. What is the ratio of the Revenue generated (in %) of Taxes on international trade in 2005 to that in 2006?
Ensure brevity in your answer.  1.88. What is the ratio of the Revenue generated (in %) in Taxes on goods and services in 2005 to that in 2007?
Provide a succinct answer. 2.19. What is the ratio of the Revenue generated (in %) in Taxes on income in 2005 to that in 2007?
Make the answer very short. 1.43. What is the ratio of the Revenue generated (in %) in Taxes on international trade in 2005 to that in 2007?
Keep it short and to the point. 1.46. What is the ratio of the Revenue generated (in %) of Taxes on goods and services in 2005 to that in 2008?
Provide a short and direct response. 1.47. What is the ratio of the Revenue generated (in %) of Taxes on income in 2005 to that in 2008?
Your answer should be compact. 1.15. What is the ratio of the Revenue generated (in %) in Taxes on international trade in 2005 to that in 2008?
Your answer should be compact. 1.15. What is the ratio of the Revenue generated (in %) in Taxes on goods and services in 2005 to that in 2009?
Provide a succinct answer. 0.94. What is the ratio of the Revenue generated (in %) of Taxes on income in 2005 to that in 2009?
Make the answer very short. 1.02. What is the ratio of the Revenue generated (in %) in Taxes on international trade in 2005 to that in 2009?
Ensure brevity in your answer.  0.38. What is the ratio of the Revenue generated (in %) in Taxes on goods and services in 2005 to that in 2010?
Your response must be concise. 1.52. What is the ratio of the Revenue generated (in %) in Taxes on income in 2005 to that in 2010?
Make the answer very short. 1.64. What is the ratio of the Revenue generated (in %) of Taxes on international trade in 2005 to that in 2010?
Provide a short and direct response. 0.85. What is the ratio of the Revenue generated (in %) of Taxes on goods and services in 2006 to that in 2007?
Your answer should be very brief. 1.44. What is the ratio of the Revenue generated (in %) in Taxes on income in 2006 to that in 2007?
Give a very brief answer. 1.1. What is the ratio of the Revenue generated (in %) of Taxes on international trade in 2006 to that in 2007?
Ensure brevity in your answer.  0.78. What is the ratio of the Revenue generated (in %) in Taxes on goods and services in 2006 to that in 2008?
Offer a terse response. 0.97. What is the ratio of the Revenue generated (in %) in Taxes on income in 2006 to that in 2008?
Your response must be concise. 0.89. What is the ratio of the Revenue generated (in %) of Taxes on international trade in 2006 to that in 2008?
Give a very brief answer. 0.61. What is the ratio of the Revenue generated (in %) of Taxes on goods and services in 2006 to that in 2009?
Offer a terse response. 0.62. What is the ratio of the Revenue generated (in %) in Taxes on income in 2006 to that in 2009?
Offer a very short reply. 0.79. What is the ratio of the Revenue generated (in %) of Taxes on international trade in 2006 to that in 2009?
Offer a terse response. 0.2. What is the ratio of the Revenue generated (in %) of Taxes on income in 2006 to that in 2010?
Ensure brevity in your answer.  1.26. What is the ratio of the Revenue generated (in %) of Taxes on international trade in 2006 to that in 2010?
Your answer should be very brief. 0.46. What is the ratio of the Revenue generated (in %) in Taxes on goods and services in 2007 to that in 2008?
Keep it short and to the point. 0.67. What is the ratio of the Revenue generated (in %) of Taxes on income in 2007 to that in 2008?
Provide a short and direct response. 0.8. What is the ratio of the Revenue generated (in %) of Taxes on international trade in 2007 to that in 2008?
Your answer should be very brief. 0.79. What is the ratio of the Revenue generated (in %) of Taxes on goods and services in 2007 to that in 2009?
Your answer should be very brief. 0.43. What is the ratio of the Revenue generated (in %) in Taxes on income in 2007 to that in 2009?
Offer a very short reply. 0.71. What is the ratio of the Revenue generated (in %) in Taxes on international trade in 2007 to that in 2009?
Provide a short and direct response. 0.26. What is the ratio of the Revenue generated (in %) in Taxes on goods and services in 2007 to that in 2010?
Provide a succinct answer. 0.7. What is the ratio of the Revenue generated (in %) of Taxes on income in 2007 to that in 2010?
Provide a short and direct response. 1.15. What is the ratio of the Revenue generated (in %) of Taxes on international trade in 2007 to that in 2010?
Keep it short and to the point. 0.58. What is the ratio of the Revenue generated (in %) in Taxes on goods and services in 2008 to that in 2009?
Give a very brief answer. 0.64. What is the ratio of the Revenue generated (in %) of Taxes on income in 2008 to that in 2009?
Keep it short and to the point. 0.89. What is the ratio of the Revenue generated (in %) in Taxes on international trade in 2008 to that in 2009?
Provide a short and direct response. 0.33. What is the ratio of the Revenue generated (in %) of Taxes on goods and services in 2008 to that in 2010?
Offer a terse response. 1.04. What is the ratio of the Revenue generated (in %) in Taxes on income in 2008 to that in 2010?
Offer a very short reply. 1.43. What is the ratio of the Revenue generated (in %) in Taxes on international trade in 2008 to that in 2010?
Your answer should be compact. 0.74. What is the ratio of the Revenue generated (in %) of Taxes on goods and services in 2009 to that in 2010?
Your answer should be compact. 1.61. What is the ratio of the Revenue generated (in %) of Taxes on income in 2009 to that in 2010?
Your response must be concise. 1.6. What is the ratio of the Revenue generated (in %) in Taxes on international trade in 2009 to that in 2010?
Your response must be concise. 2.26. What is the difference between the highest and the second highest Revenue generated (in %) in Taxes on goods and services?
Make the answer very short. 5.24. What is the difference between the highest and the second highest Revenue generated (in %) in Taxes on income?
Offer a terse response. 1.22. What is the difference between the highest and the second highest Revenue generated (in %) in Taxes on international trade?
Provide a succinct answer. 5.57. What is the difference between the highest and the lowest Revenue generated (in %) in Taxes on goods and services?
Keep it short and to the point. 19.15. What is the difference between the highest and the lowest Revenue generated (in %) in Taxes on income?
Your answer should be very brief. 21.83. What is the difference between the highest and the lowest Revenue generated (in %) in Taxes on international trade?
Offer a very short reply. 8.93. 